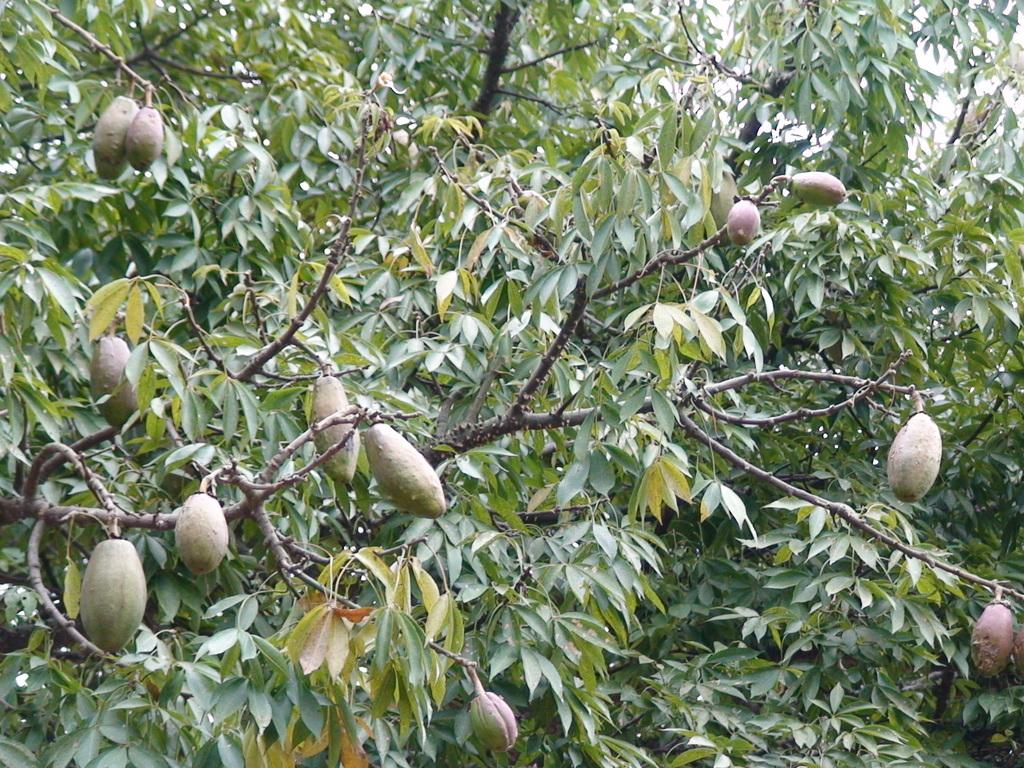What type of vegetation can be seen in the image? There are leaves and branches of trees in the image. Are there any fruits visible in the image? Yes, there are fruits in the image. What type of soap is being used to clean the fruits in the image? There is no soap or cleaning activity depicted in the image; it only shows leaves, branches of trees, and fruits. 